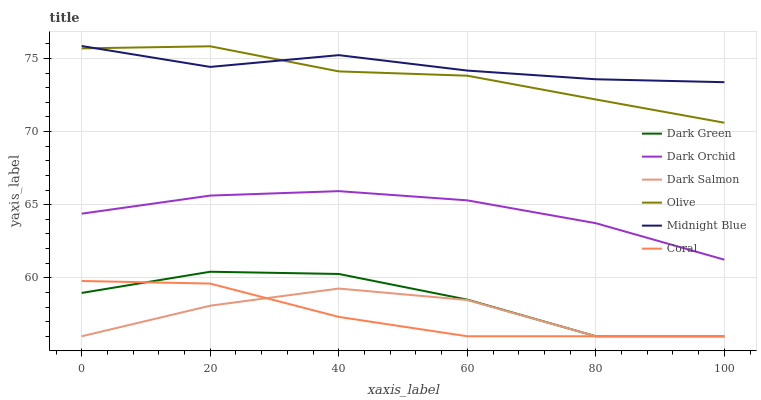Does Coral have the minimum area under the curve?
Answer yes or no. Yes. Does Midnight Blue have the maximum area under the curve?
Answer yes or no. Yes. Does Dark Salmon have the minimum area under the curve?
Answer yes or no. No. Does Dark Salmon have the maximum area under the curve?
Answer yes or no. No. Is Dark Orchid the smoothest?
Answer yes or no. Yes. Is Dark Salmon the roughest?
Answer yes or no. Yes. Is Coral the smoothest?
Answer yes or no. No. Is Coral the roughest?
Answer yes or no. No. Does Coral have the lowest value?
Answer yes or no. Yes. Does Dark Orchid have the lowest value?
Answer yes or no. No. Does Midnight Blue have the highest value?
Answer yes or no. Yes. Does Coral have the highest value?
Answer yes or no. No. Is Dark Orchid less than Olive?
Answer yes or no. Yes. Is Olive greater than Dark Salmon?
Answer yes or no. Yes. Does Dark Green intersect Dark Salmon?
Answer yes or no. Yes. Is Dark Green less than Dark Salmon?
Answer yes or no. No. Is Dark Green greater than Dark Salmon?
Answer yes or no. No. Does Dark Orchid intersect Olive?
Answer yes or no. No. 